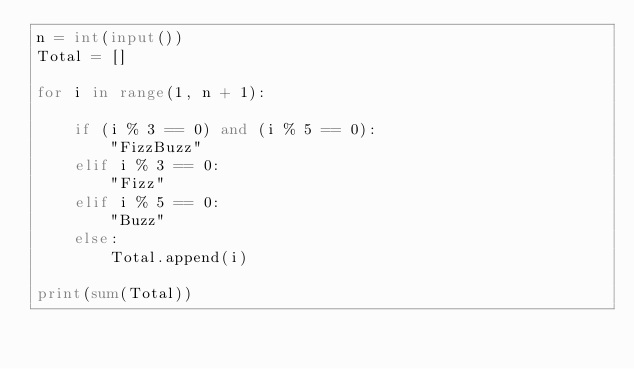Convert code to text. <code><loc_0><loc_0><loc_500><loc_500><_Python_>n = int(input())
Total = []

for i in range(1, n + 1):

    if (i % 3 == 0) and (i % 5 == 0):
        "FizzBuzz"
    elif i % 3 == 0:
        "Fizz"
    elif i % 5 == 0:
        "Buzz"
    else:
        Total.append(i)

print(sum(Total))</code> 